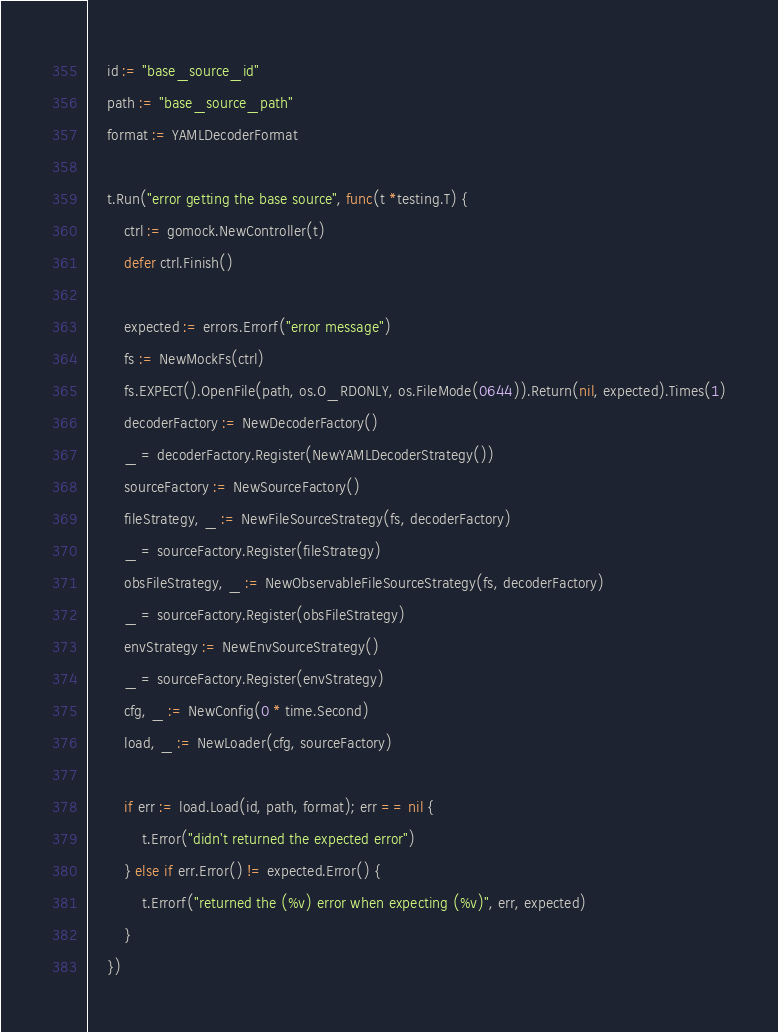Convert code to text. <code><loc_0><loc_0><loc_500><loc_500><_Go_>	id := "base_source_id"
	path := "base_source_path"
	format := YAMLDecoderFormat

	t.Run("error getting the base source", func(t *testing.T) {
		ctrl := gomock.NewController(t)
		defer ctrl.Finish()

		expected := errors.Errorf("error message")
		fs := NewMockFs(ctrl)
		fs.EXPECT().OpenFile(path, os.O_RDONLY, os.FileMode(0644)).Return(nil, expected).Times(1)
		decoderFactory := NewDecoderFactory()
		_ = decoderFactory.Register(NewYAMLDecoderStrategy())
		sourceFactory := NewSourceFactory()
		fileStrategy, _ := NewFileSourceStrategy(fs, decoderFactory)
		_ = sourceFactory.Register(fileStrategy)
		obsFileStrategy, _ := NewObservableFileSourceStrategy(fs, decoderFactory)
		_ = sourceFactory.Register(obsFileStrategy)
		envStrategy := NewEnvSourceStrategy()
		_ = sourceFactory.Register(envStrategy)
		cfg, _ := NewConfig(0 * time.Second)
		load, _ := NewLoader(cfg, sourceFactory)

		if err := load.Load(id, path, format); err == nil {
			t.Error("didn't returned the expected error")
		} else if err.Error() != expected.Error() {
			t.Errorf("returned the (%v) error when expecting (%v)", err, expected)
		}
	})
</code> 